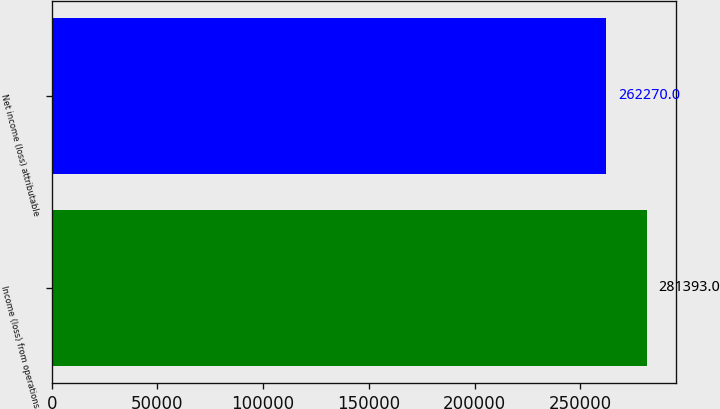Convert chart. <chart><loc_0><loc_0><loc_500><loc_500><bar_chart><fcel>Income (loss) from operations<fcel>Net income (loss) attributable<nl><fcel>281393<fcel>262270<nl></chart> 